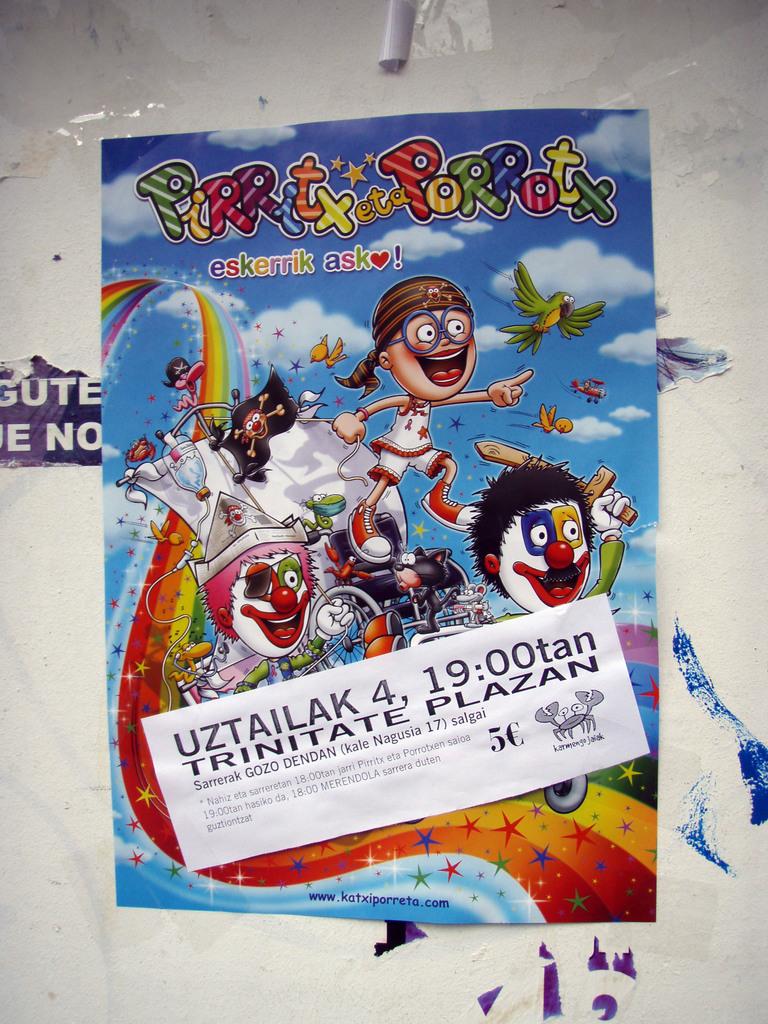What does number is on the sticker?
Keep it short and to the point. 4. What is the time on the white paper?
Provide a short and direct response. 19:00. 